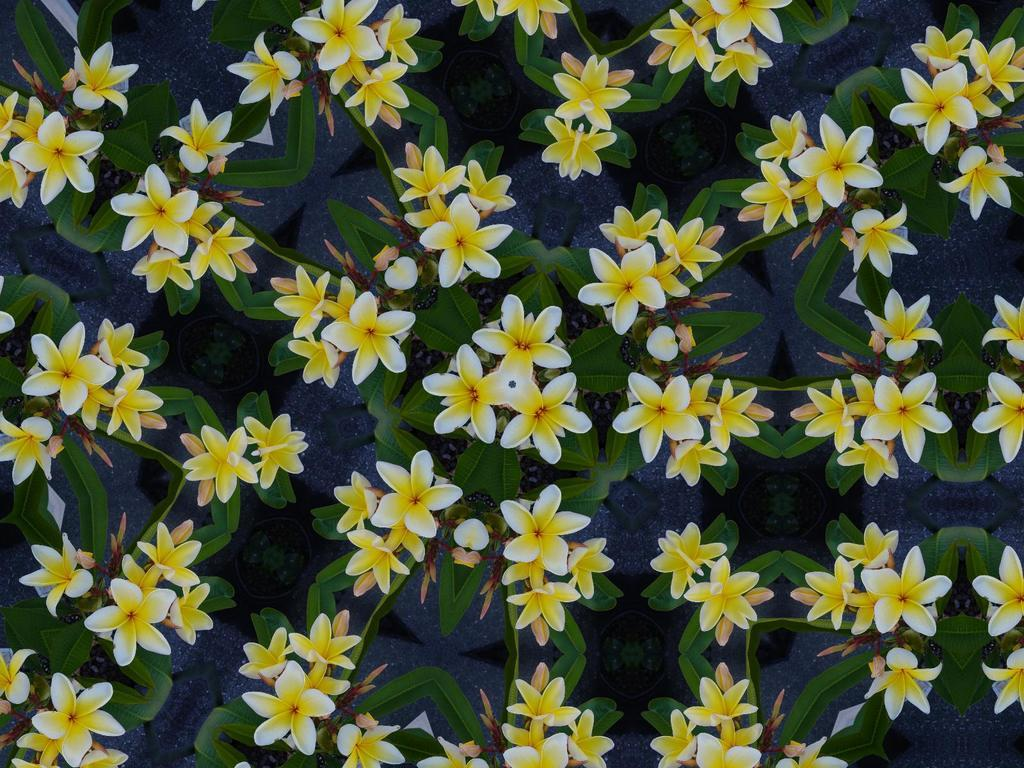What type of plants can be seen in the image? There are flowers and leaves in the image. Can you describe the appearance of the flowers? Unfortunately, the specific appearance of the flowers cannot be determined from the provided facts. What else is present in the image besides the flowers and leaves? Based on the given facts, there is no additional information about other elements in the image. Where is the station located in the image? There is no station present in the image; it only contains flowers and leaves. Is there a carriage visible in the image? No, there is no carriage present in the image. 